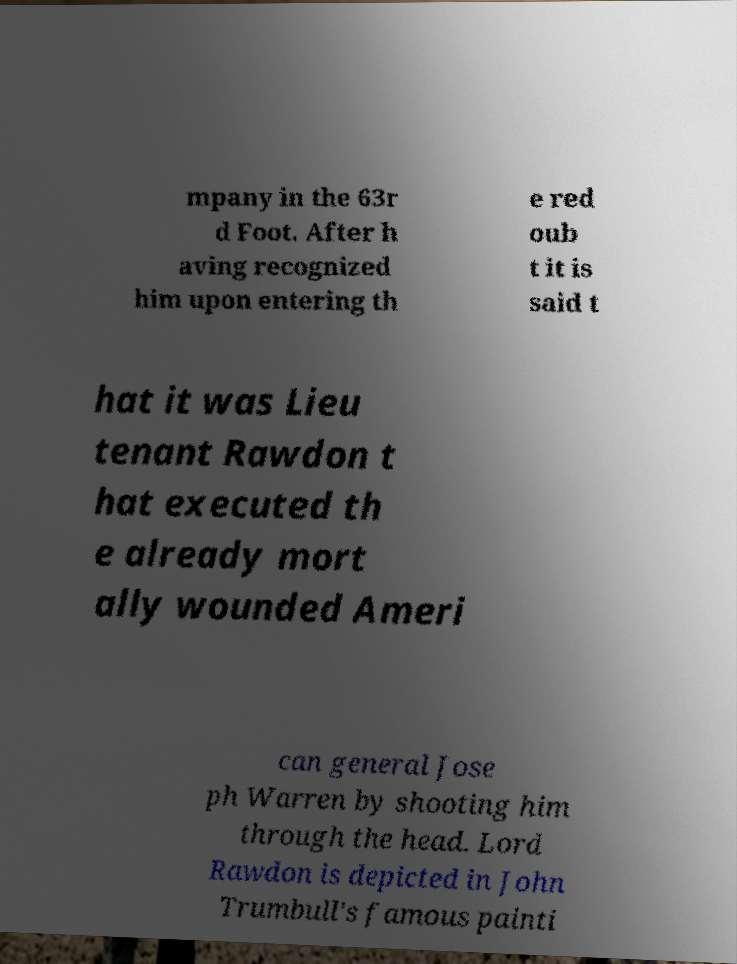There's text embedded in this image that I need extracted. Can you transcribe it verbatim? mpany in the 63r d Foot. After h aving recognized him upon entering th e red oub t it is said t hat it was Lieu tenant Rawdon t hat executed th e already mort ally wounded Ameri can general Jose ph Warren by shooting him through the head. Lord Rawdon is depicted in John Trumbull's famous painti 